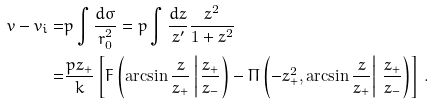Convert formula to latex. <formula><loc_0><loc_0><loc_500><loc_500>v - v _ { i } = & p \int \frac { d \sigma } { r _ { 0 } ^ { 2 } } = p \int \frac { d z } { z ^ { \prime } } \frac { z ^ { 2 } } { 1 + z ^ { 2 } } \\ = & \frac { p z _ { + } } { k } \left [ F \left ( \arcsin \frac { z } { z _ { + } } \left | \, \frac { z _ { + } } { z _ { - } } \right ) - \Pi \left ( - z _ { + } ^ { 2 } , \arcsin \frac { z } { z _ { + } } \right | \, \frac { z _ { + } } { z _ { - } } \right ) \right ] \, .</formula> 